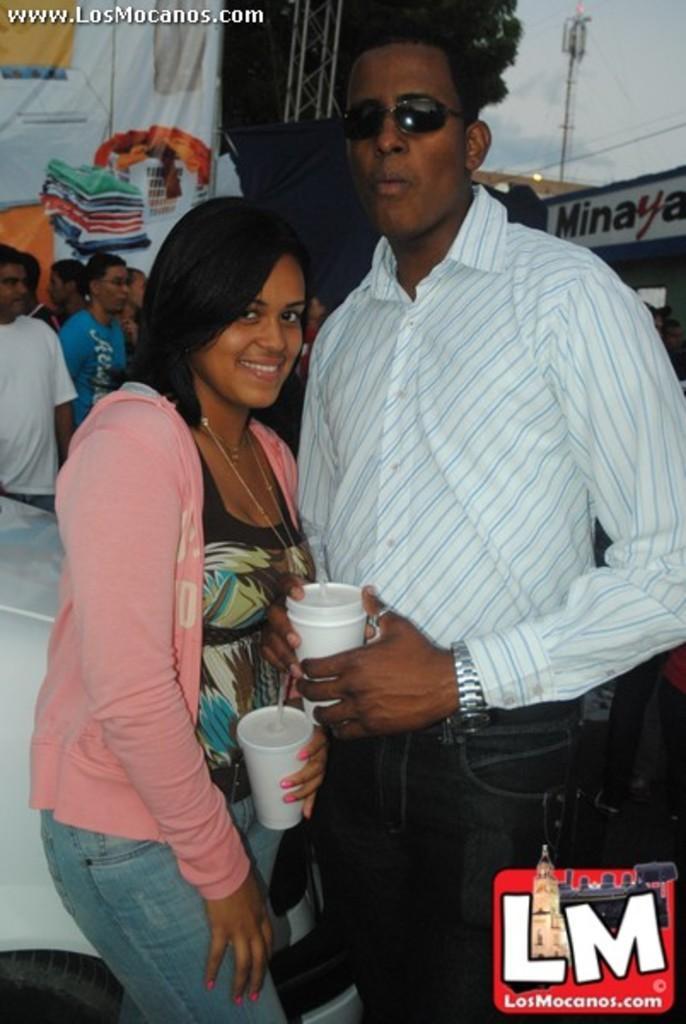Could you give a brief overview of what you see in this image? In this image there is a man and a woman with a smile on their face, holding cups are posing for the camera, behind them there are few other people standing. 